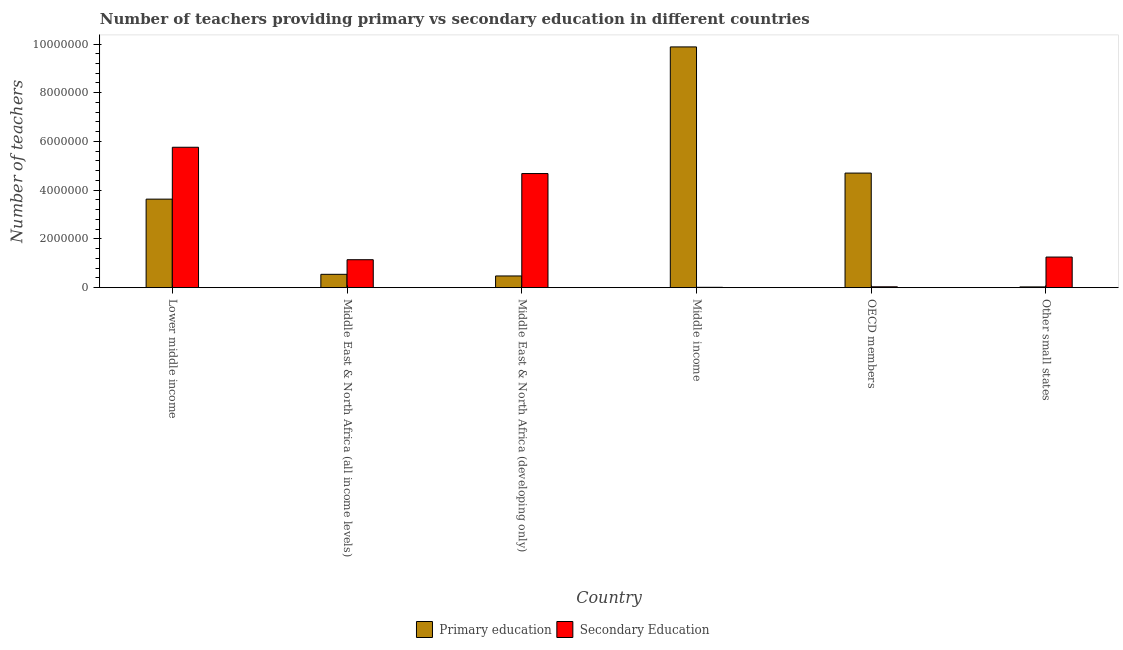How many different coloured bars are there?
Offer a terse response. 2. How many groups of bars are there?
Provide a succinct answer. 6. Are the number of bars per tick equal to the number of legend labels?
Give a very brief answer. Yes. Are the number of bars on each tick of the X-axis equal?
Offer a very short reply. Yes. How many bars are there on the 5th tick from the left?
Give a very brief answer. 2. What is the label of the 1st group of bars from the left?
Keep it short and to the point. Lower middle income. What is the number of primary teachers in Other small states?
Give a very brief answer. 3.11e+04. Across all countries, what is the maximum number of secondary teachers?
Your answer should be very brief. 5.76e+06. Across all countries, what is the minimum number of secondary teachers?
Provide a succinct answer. 1.45e+04. In which country was the number of primary teachers maximum?
Provide a succinct answer. Middle income. What is the total number of primary teachers in the graph?
Provide a short and direct response. 1.93e+07. What is the difference between the number of primary teachers in Middle East & North Africa (all income levels) and that in Other small states?
Keep it short and to the point. 5.17e+05. What is the difference between the number of secondary teachers in Middle income and the number of primary teachers in Middle East & North Africa (developing only)?
Your answer should be compact. -4.66e+05. What is the average number of secondary teachers per country?
Provide a succinct answer. 2.15e+06. What is the difference between the number of primary teachers and number of secondary teachers in Lower middle income?
Your answer should be compact. -2.13e+06. In how many countries, is the number of primary teachers greater than 4800000 ?
Give a very brief answer. 1. What is the ratio of the number of primary teachers in Lower middle income to that in Middle East & North Africa (developing only)?
Make the answer very short. 7.56. What is the difference between the highest and the second highest number of secondary teachers?
Your response must be concise. 1.08e+06. What is the difference between the highest and the lowest number of primary teachers?
Your answer should be very brief. 9.85e+06. In how many countries, is the number of secondary teachers greater than the average number of secondary teachers taken over all countries?
Provide a short and direct response. 2. What does the 2nd bar from the left in Middle income represents?
Your response must be concise. Secondary Education. What does the 1st bar from the right in Middle East & North Africa (all income levels) represents?
Keep it short and to the point. Secondary Education. Does the graph contain grids?
Make the answer very short. No. How are the legend labels stacked?
Provide a succinct answer. Horizontal. What is the title of the graph?
Make the answer very short. Number of teachers providing primary vs secondary education in different countries. Does "Age 15+" appear as one of the legend labels in the graph?
Give a very brief answer. No. What is the label or title of the Y-axis?
Your response must be concise. Number of teachers. What is the Number of teachers in Primary education in Lower middle income?
Provide a succinct answer. 3.63e+06. What is the Number of teachers in Secondary Education in Lower middle income?
Make the answer very short. 5.76e+06. What is the Number of teachers of Primary education in Middle East & North Africa (all income levels)?
Give a very brief answer. 5.48e+05. What is the Number of teachers in Secondary Education in Middle East & North Africa (all income levels)?
Ensure brevity in your answer.  1.15e+06. What is the Number of teachers of Primary education in Middle East & North Africa (developing only)?
Keep it short and to the point. 4.80e+05. What is the Number of teachers in Secondary Education in Middle East & North Africa (developing only)?
Your answer should be compact. 4.68e+06. What is the Number of teachers in Primary education in Middle income?
Give a very brief answer. 9.88e+06. What is the Number of teachers of Secondary Education in Middle income?
Your response must be concise. 1.45e+04. What is the Number of teachers of Primary education in OECD members?
Offer a terse response. 4.70e+06. What is the Number of teachers of Secondary Education in OECD members?
Give a very brief answer. 3.51e+04. What is the Number of teachers of Primary education in Other small states?
Your answer should be compact. 3.11e+04. What is the Number of teachers of Secondary Education in Other small states?
Your answer should be very brief. 1.26e+06. Across all countries, what is the maximum Number of teachers of Primary education?
Offer a very short reply. 9.88e+06. Across all countries, what is the maximum Number of teachers in Secondary Education?
Keep it short and to the point. 5.76e+06. Across all countries, what is the minimum Number of teachers in Primary education?
Give a very brief answer. 3.11e+04. Across all countries, what is the minimum Number of teachers of Secondary Education?
Keep it short and to the point. 1.45e+04. What is the total Number of teachers of Primary education in the graph?
Provide a short and direct response. 1.93e+07. What is the total Number of teachers in Secondary Education in the graph?
Your response must be concise. 1.29e+07. What is the difference between the Number of teachers of Primary education in Lower middle income and that in Middle East & North Africa (all income levels)?
Provide a short and direct response. 3.09e+06. What is the difference between the Number of teachers of Secondary Education in Lower middle income and that in Middle East & North Africa (all income levels)?
Offer a terse response. 4.62e+06. What is the difference between the Number of teachers in Primary education in Lower middle income and that in Middle East & North Africa (developing only)?
Offer a terse response. 3.15e+06. What is the difference between the Number of teachers of Secondary Education in Lower middle income and that in Middle East & North Africa (developing only)?
Ensure brevity in your answer.  1.08e+06. What is the difference between the Number of teachers in Primary education in Lower middle income and that in Middle income?
Give a very brief answer. -6.25e+06. What is the difference between the Number of teachers of Secondary Education in Lower middle income and that in Middle income?
Provide a short and direct response. 5.75e+06. What is the difference between the Number of teachers in Primary education in Lower middle income and that in OECD members?
Keep it short and to the point. -1.07e+06. What is the difference between the Number of teachers in Secondary Education in Lower middle income and that in OECD members?
Provide a succinct answer. 5.73e+06. What is the difference between the Number of teachers of Primary education in Lower middle income and that in Other small states?
Keep it short and to the point. 3.60e+06. What is the difference between the Number of teachers in Secondary Education in Lower middle income and that in Other small states?
Ensure brevity in your answer.  4.51e+06. What is the difference between the Number of teachers in Primary education in Middle East & North Africa (all income levels) and that in Middle East & North Africa (developing only)?
Keep it short and to the point. 6.73e+04. What is the difference between the Number of teachers of Secondary Education in Middle East & North Africa (all income levels) and that in Middle East & North Africa (developing only)?
Your answer should be very brief. -3.54e+06. What is the difference between the Number of teachers in Primary education in Middle East & North Africa (all income levels) and that in Middle income?
Give a very brief answer. -9.33e+06. What is the difference between the Number of teachers in Secondary Education in Middle East & North Africa (all income levels) and that in Middle income?
Offer a very short reply. 1.13e+06. What is the difference between the Number of teachers in Primary education in Middle East & North Africa (all income levels) and that in OECD members?
Give a very brief answer. -4.15e+06. What is the difference between the Number of teachers of Secondary Education in Middle East & North Africa (all income levels) and that in OECD members?
Give a very brief answer. 1.11e+06. What is the difference between the Number of teachers in Primary education in Middle East & North Africa (all income levels) and that in Other small states?
Your response must be concise. 5.17e+05. What is the difference between the Number of teachers in Secondary Education in Middle East & North Africa (all income levels) and that in Other small states?
Offer a very short reply. -1.09e+05. What is the difference between the Number of teachers in Primary education in Middle East & North Africa (developing only) and that in Middle income?
Make the answer very short. -9.40e+06. What is the difference between the Number of teachers of Secondary Education in Middle East & North Africa (developing only) and that in Middle income?
Your answer should be compact. 4.67e+06. What is the difference between the Number of teachers in Primary education in Middle East & North Africa (developing only) and that in OECD members?
Make the answer very short. -4.22e+06. What is the difference between the Number of teachers in Secondary Education in Middle East & North Africa (developing only) and that in OECD members?
Your response must be concise. 4.65e+06. What is the difference between the Number of teachers in Primary education in Middle East & North Africa (developing only) and that in Other small states?
Your response must be concise. 4.49e+05. What is the difference between the Number of teachers in Secondary Education in Middle East & North Africa (developing only) and that in Other small states?
Make the answer very short. 3.43e+06. What is the difference between the Number of teachers of Primary education in Middle income and that in OECD members?
Your answer should be very brief. 5.18e+06. What is the difference between the Number of teachers in Secondary Education in Middle income and that in OECD members?
Your response must be concise. -2.06e+04. What is the difference between the Number of teachers in Primary education in Middle income and that in Other small states?
Provide a succinct answer. 9.85e+06. What is the difference between the Number of teachers of Secondary Education in Middle income and that in Other small states?
Ensure brevity in your answer.  -1.24e+06. What is the difference between the Number of teachers in Primary education in OECD members and that in Other small states?
Ensure brevity in your answer.  4.67e+06. What is the difference between the Number of teachers in Secondary Education in OECD members and that in Other small states?
Keep it short and to the point. -1.22e+06. What is the difference between the Number of teachers of Primary education in Lower middle income and the Number of teachers of Secondary Education in Middle East & North Africa (all income levels)?
Give a very brief answer. 2.49e+06. What is the difference between the Number of teachers in Primary education in Lower middle income and the Number of teachers in Secondary Education in Middle East & North Africa (developing only)?
Your response must be concise. -1.05e+06. What is the difference between the Number of teachers in Primary education in Lower middle income and the Number of teachers in Secondary Education in Middle income?
Offer a terse response. 3.62e+06. What is the difference between the Number of teachers in Primary education in Lower middle income and the Number of teachers in Secondary Education in OECD members?
Your response must be concise. 3.60e+06. What is the difference between the Number of teachers in Primary education in Lower middle income and the Number of teachers in Secondary Education in Other small states?
Give a very brief answer. 2.38e+06. What is the difference between the Number of teachers in Primary education in Middle East & North Africa (all income levels) and the Number of teachers in Secondary Education in Middle East & North Africa (developing only)?
Offer a very short reply. -4.14e+06. What is the difference between the Number of teachers of Primary education in Middle East & North Africa (all income levels) and the Number of teachers of Secondary Education in Middle income?
Ensure brevity in your answer.  5.33e+05. What is the difference between the Number of teachers in Primary education in Middle East & North Africa (all income levels) and the Number of teachers in Secondary Education in OECD members?
Your response must be concise. 5.13e+05. What is the difference between the Number of teachers in Primary education in Middle East & North Africa (all income levels) and the Number of teachers in Secondary Education in Other small states?
Give a very brief answer. -7.08e+05. What is the difference between the Number of teachers in Primary education in Middle East & North Africa (developing only) and the Number of teachers in Secondary Education in Middle income?
Your response must be concise. 4.66e+05. What is the difference between the Number of teachers in Primary education in Middle East & North Africa (developing only) and the Number of teachers in Secondary Education in OECD members?
Give a very brief answer. 4.45e+05. What is the difference between the Number of teachers of Primary education in Middle East & North Africa (developing only) and the Number of teachers of Secondary Education in Other small states?
Offer a very short reply. -7.76e+05. What is the difference between the Number of teachers of Primary education in Middle income and the Number of teachers of Secondary Education in OECD members?
Your response must be concise. 9.85e+06. What is the difference between the Number of teachers in Primary education in Middle income and the Number of teachers in Secondary Education in Other small states?
Provide a succinct answer. 8.62e+06. What is the difference between the Number of teachers in Primary education in OECD members and the Number of teachers in Secondary Education in Other small states?
Ensure brevity in your answer.  3.45e+06. What is the average Number of teachers in Primary education per country?
Your answer should be compact. 3.21e+06. What is the average Number of teachers of Secondary Education per country?
Give a very brief answer. 2.15e+06. What is the difference between the Number of teachers in Primary education and Number of teachers in Secondary Education in Lower middle income?
Your answer should be compact. -2.13e+06. What is the difference between the Number of teachers in Primary education and Number of teachers in Secondary Education in Middle East & North Africa (all income levels)?
Provide a succinct answer. -5.99e+05. What is the difference between the Number of teachers in Primary education and Number of teachers in Secondary Education in Middle East & North Africa (developing only)?
Keep it short and to the point. -4.20e+06. What is the difference between the Number of teachers in Primary education and Number of teachers in Secondary Education in Middle income?
Offer a very short reply. 9.87e+06. What is the difference between the Number of teachers of Primary education and Number of teachers of Secondary Education in OECD members?
Offer a very short reply. 4.67e+06. What is the difference between the Number of teachers of Primary education and Number of teachers of Secondary Education in Other small states?
Make the answer very short. -1.23e+06. What is the ratio of the Number of teachers in Primary education in Lower middle income to that in Middle East & North Africa (all income levels)?
Offer a terse response. 6.63. What is the ratio of the Number of teachers of Secondary Education in Lower middle income to that in Middle East & North Africa (all income levels)?
Your answer should be compact. 5.02. What is the ratio of the Number of teachers of Primary education in Lower middle income to that in Middle East & North Africa (developing only)?
Provide a succinct answer. 7.56. What is the ratio of the Number of teachers of Secondary Education in Lower middle income to that in Middle East & North Africa (developing only)?
Your answer should be compact. 1.23. What is the ratio of the Number of teachers of Primary education in Lower middle income to that in Middle income?
Offer a terse response. 0.37. What is the ratio of the Number of teachers of Secondary Education in Lower middle income to that in Middle income?
Provide a succinct answer. 397.7. What is the ratio of the Number of teachers in Primary education in Lower middle income to that in OECD members?
Your response must be concise. 0.77. What is the ratio of the Number of teachers in Secondary Education in Lower middle income to that in OECD members?
Provide a short and direct response. 164.08. What is the ratio of the Number of teachers in Primary education in Lower middle income to that in Other small states?
Make the answer very short. 116.91. What is the ratio of the Number of teachers in Secondary Education in Lower middle income to that in Other small states?
Offer a very short reply. 4.59. What is the ratio of the Number of teachers in Primary education in Middle East & North Africa (all income levels) to that in Middle East & North Africa (developing only)?
Your answer should be compact. 1.14. What is the ratio of the Number of teachers of Secondary Education in Middle East & North Africa (all income levels) to that in Middle East & North Africa (developing only)?
Keep it short and to the point. 0.24. What is the ratio of the Number of teachers in Primary education in Middle East & North Africa (all income levels) to that in Middle income?
Make the answer very short. 0.06. What is the ratio of the Number of teachers in Secondary Education in Middle East & North Africa (all income levels) to that in Middle income?
Give a very brief answer. 79.18. What is the ratio of the Number of teachers in Primary education in Middle East & North Africa (all income levels) to that in OECD members?
Keep it short and to the point. 0.12. What is the ratio of the Number of teachers of Secondary Education in Middle East & North Africa (all income levels) to that in OECD members?
Keep it short and to the point. 32.67. What is the ratio of the Number of teachers of Primary education in Middle East & North Africa (all income levels) to that in Other small states?
Your answer should be very brief. 17.62. What is the ratio of the Number of teachers in Secondary Education in Middle East & North Africa (all income levels) to that in Other small states?
Provide a short and direct response. 0.91. What is the ratio of the Number of teachers of Primary education in Middle East & North Africa (developing only) to that in Middle income?
Offer a very short reply. 0.05. What is the ratio of the Number of teachers of Secondary Education in Middle East & North Africa (developing only) to that in Middle income?
Make the answer very short. 323.24. What is the ratio of the Number of teachers of Primary education in Middle East & North Africa (developing only) to that in OECD members?
Give a very brief answer. 0.1. What is the ratio of the Number of teachers in Secondary Education in Middle East & North Africa (developing only) to that in OECD members?
Make the answer very short. 133.36. What is the ratio of the Number of teachers of Primary education in Middle East & North Africa (developing only) to that in Other small states?
Your answer should be compact. 15.46. What is the ratio of the Number of teachers of Secondary Education in Middle East & North Africa (developing only) to that in Other small states?
Your answer should be very brief. 3.73. What is the ratio of the Number of teachers in Primary education in Middle income to that in OECD members?
Your answer should be compact. 2.1. What is the ratio of the Number of teachers of Secondary Education in Middle income to that in OECD members?
Your answer should be very brief. 0.41. What is the ratio of the Number of teachers in Primary education in Middle income to that in Other small states?
Keep it short and to the point. 317.91. What is the ratio of the Number of teachers of Secondary Education in Middle income to that in Other small states?
Provide a short and direct response. 0.01. What is the ratio of the Number of teachers in Primary education in OECD members to that in Other small states?
Provide a succinct answer. 151.29. What is the ratio of the Number of teachers of Secondary Education in OECD members to that in Other small states?
Your answer should be compact. 0.03. What is the difference between the highest and the second highest Number of teachers of Primary education?
Ensure brevity in your answer.  5.18e+06. What is the difference between the highest and the second highest Number of teachers of Secondary Education?
Keep it short and to the point. 1.08e+06. What is the difference between the highest and the lowest Number of teachers of Primary education?
Provide a succinct answer. 9.85e+06. What is the difference between the highest and the lowest Number of teachers in Secondary Education?
Offer a very short reply. 5.75e+06. 